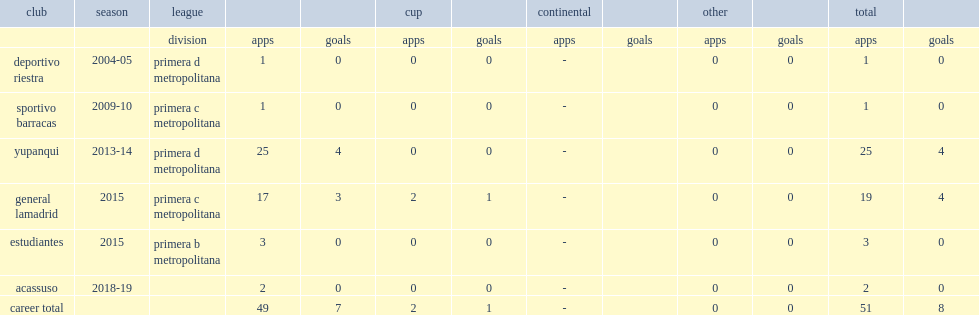Which club did godoy play for in 2004-05? Deportivo riestra. 